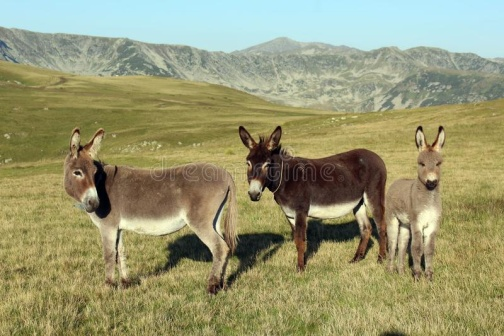Describe an imaginative short story involving these donkeys and the mountains. Once upon a time, in a valley surrounded by towering mountains, three donkeys set out on an adventure. The gray donkey was named Luna, the brown one was Bruno, and the smallest gray one was Nino. They had heard of an ancient legend that spoke of a magical spring hidden deep within the mountains, a spring that bestowed eternal wisdom on those who drank from it. Determined and curious, Luna led the way, with Bruno and Nino following closely. They navigated through lush meadows, crossed bubbling streams, and climbed rocky passes, all the while marveling at the beauty that surrounded them. As they reached the spring, they were greeted by the Guardian of the Mountains, a wise old eagle who tested their virtues of bravery, kindness, and wisdom. Passing the test, they drank from the magical spring, gaining not eternal wisdom, but a profound understanding and appreciation for the life and beauty around them. And so, they returned to their valley, not just as ordinary donkeys, but as revered keepers of the mountain's wisdom, forever transformed by their journey. 